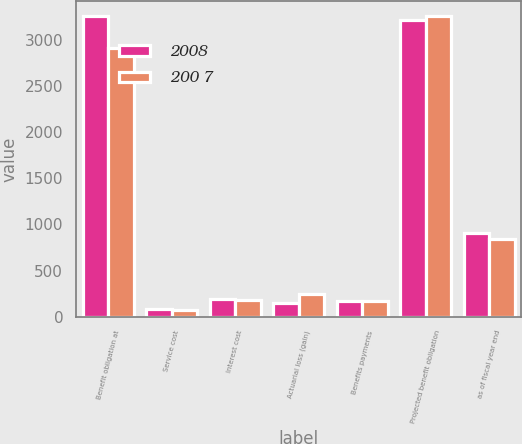Convert chart. <chart><loc_0><loc_0><loc_500><loc_500><stacked_bar_chart><ecel><fcel>Benefit obligation at<fcel>Service cost<fcel>Interest cost<fcel>Actuarial loss (gain)<fcel>Benefits payments<fcel>Projected benefit obligation<fcel>as of fiscal year end<nl><fcel>2008<fcel>3257.5<fcel>80.1<fcel>196.7<fcel>147.1<fcel>168<fcel>3224.1<fcel>904.6<nl><fcel>200 7<fcel>2916.4<fcel>73.1<fcel>185.6<fcel>244<fcel>164.2<fcel>3257.5<fcel>840.3<nl></chart> 